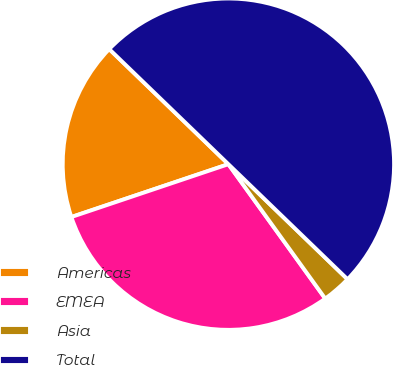Convert chart. <chart><loc_0><loc_0><loc_500><loc_500><pie_chart><fcel>Americas<fcel>EMEA<fcel>Asia<fcel>Total<nl><fcel>17.39%<fcel>29.77%<fcel>2.84%<fcel>50.0%<nl></chart> 